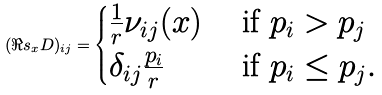<formula> <loc_0><loc_0><loc_500><loc_500>( \Re s _ { x } D ) _ { i j } = \begin{cases} \frac { 1 } { r } \nu _ { i j } ( x ) & \text { if } p _ { i } > p _ { j } \\ \delta _ { i j } \frac { p _ { i } } { r } & \text { if } p _ { i } \leq p _ { j } . \end{cases}</formula> 